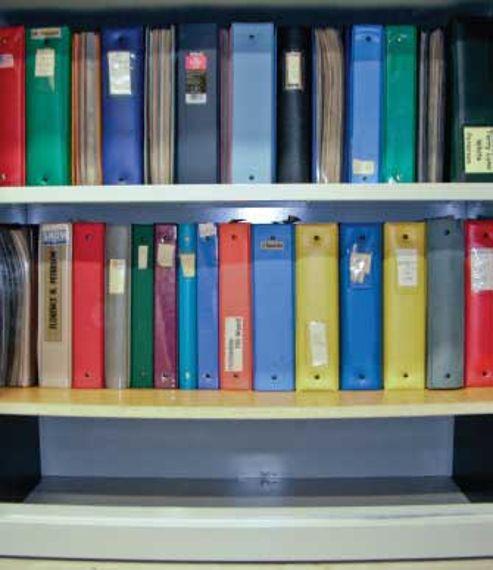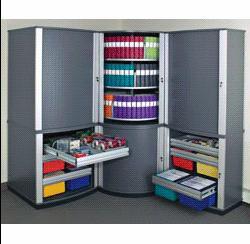The first image is the image on the left, the second image is the image on the right. Evaluate the accuracy of this statement regarding the images: "One image shows binders of various colors arranged vertically on tiered shelves.". Is it true? Answer yes or no. Yes. The first image is the image on the left, the second image is the image on the right. Analyze the images presented: Is the assertion "In one of the images there are stacks of books not on a shelf." valid? Answer yes or no. No. 